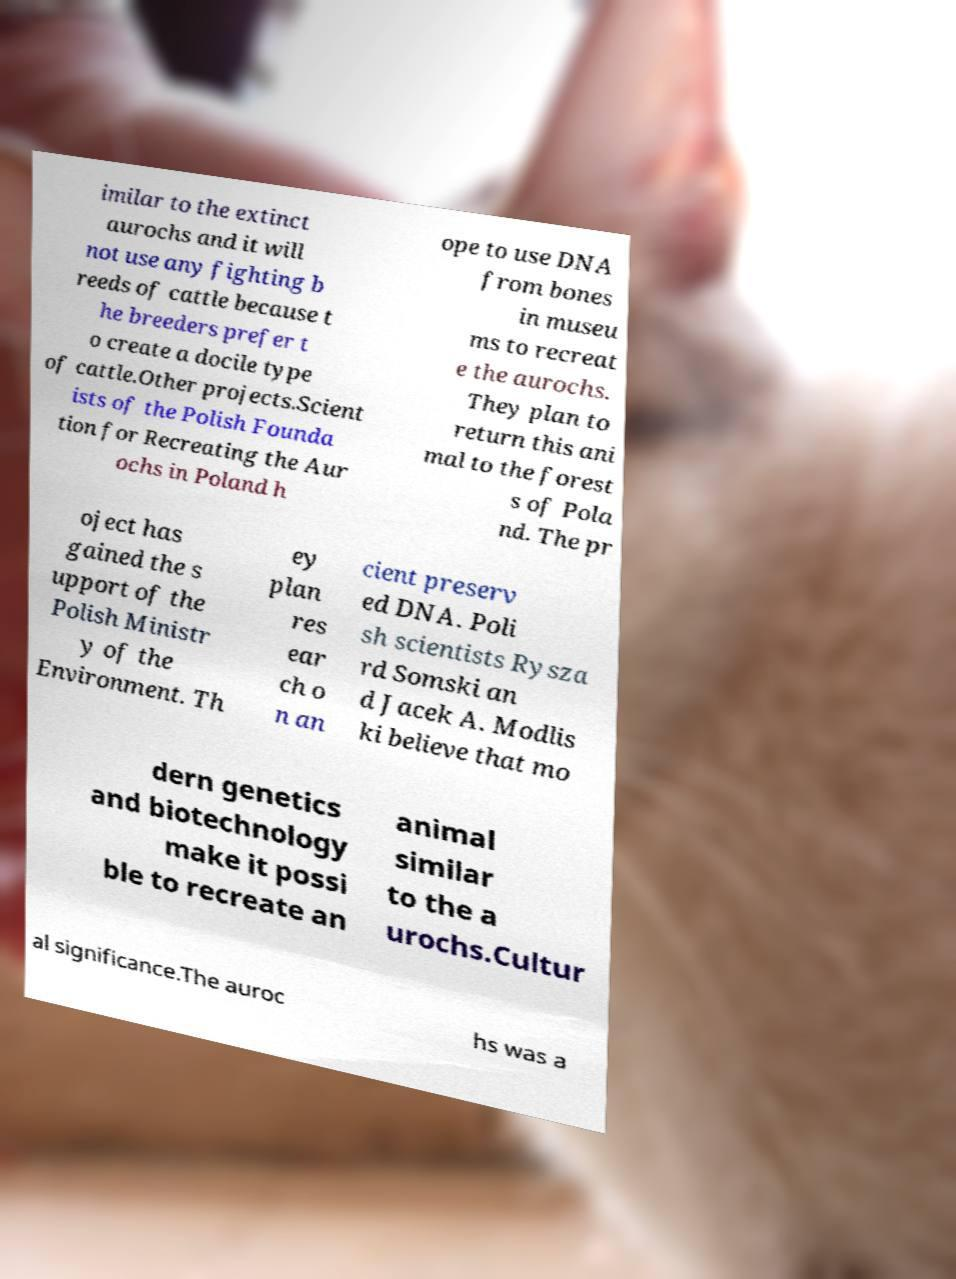There's text embedded in this image that I need extracted. Can you transcribe it verbatim? imilar to the extinct aurochs and it will not use any fighting b reeds of cattle because t he breeders prefer t o create a docile type of cattle.Other projects.Scient ists of the Polish Founda tion for Recreating the Aur ochs in Poland h ope to use DNA from bones in museu ms to recreat e the aurochs. They plan to return this ani mal to the forest s of Pola nd. The pr oject has gained the s upport of the Polish Ministr y of the Environment. Th ey plan res ear ch o n an cient preserv ed DNA. Poli sh scientists Rysza rd Somski an d Jacek A. Modlis ki believe that mo dern genetics and biotechnology make it possi ble to recreate an animal similar to the a urochs.Cultur al significance.The auroc hs was a 